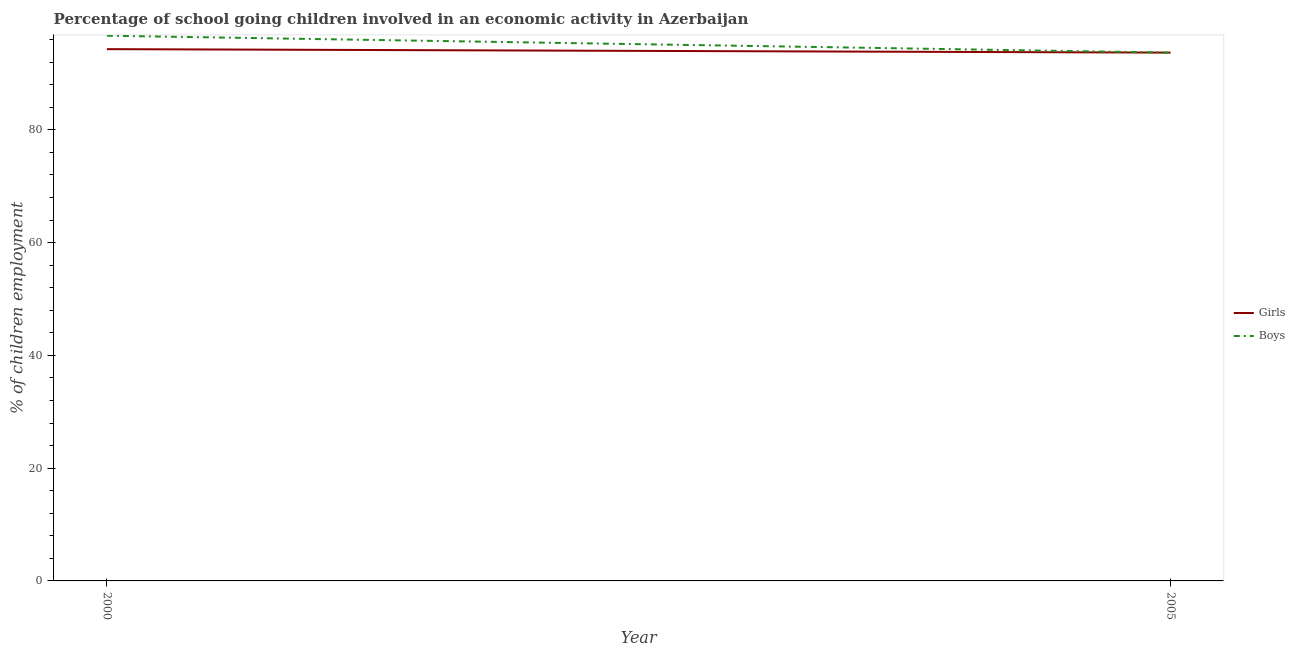Does the line corresponding to percentage of school going boys intersect with the line corresponding to percentage of school going girls?
Offer a terse response. Yes. What is the percentage of school going boys in 2005?
Ensure brevity in your answer.  93.7. Across all years, what is the maximum percentage of school going girls?
Your answer should be very brief. 94.32. Across all years, what is the minimum percentage of school going boys?
Your response must be concise. 93.7. In which year was the percentage of school going girls minimum?
Offer a very short reply. 2005. What is the total percentage of school going boys in the graph?
Your answer should be very brief. 190.4. What is the difference between the percentage of school going boys in 2000 and that in 2005?
Offer a very short reply. 3. What is the difference between the percentage of school going boys in 2005 and the percentage of school going girls in 2000?
Keep it short and to the point. -0.62. What is the average percentage of school going girls per year?
Provide a succinct answer. 94.01. In how many years, is the percentage of school going boys greater than 64 %?
Keep it short and to the point. 2. What is the ratio of the percentage of school going boys in 2000 to that in 2005?
Offer a very short reply. 1.03. In how many years, is the percentage of school going boys greater than the average percentage of school going boys taken over all years?
Offer a very short reply. 1. Does the percentage of school going girls monotonically increase over the years?
Keep it short and to the point. No. Is the percentage of school going girls strictly greater than the percentage of school going boys over the years?
Provide a succinct answer. No. Is the percentage of school going girls strictly less than the percentage of school going boys over the years?
Offer a terse response. No. How many lines are there?
Offer a very short reply. 2. What is the difference between two consecutive major ticks on the Y-axis?
Your answer should be very brief. 20. Does the graph contain any zero values?
Your response must be concise. No. How many legend labels are there?
Your answer should be very brief. 2. What is the title of the graph?
Offer a terse response. Percentage of school going children involved in an economic activity in Azerbaijan. What is the label or title of the Y-axis?
Offer a very short reply. % of children employment. What is the % of children employment in Girls in 2000?
Ensure brevity in your answer.  94.32. What is the % of children employment in Boys in 2000?
Your answer should be compact. 96.7. What is the % of children employment of Girls in 2005?
Offer a very short reply. 93.7. What is the % of children employment in Boys in 2005?
Give a very brief answer. 93.7. Across all years, what is the maximum % of children employment in Girls?
Give a very brief answer. 94.32. Across all years, what is the maximum % of children employment in Boys?
Your response must be concise. 96.7. Across all years, what is the minimum % of children employment in Girls?
Your answer should be very brief. 93.7. Across all years, what is the minimum % of children employment in Boys?
Make the answer very short. 93.7. What is the total % of children employment of Girls in the graph?
Ensure brevity in your answer.  188.02. What is the total % of children employment of Boys in the graph?
Make the answer very short. 190.4. What is the difference between the % of children employment of Girls in 2000 and that in 2005?
Offer a terse response. 0.62. What is the difference between the % of children employment in Boys in 2000 and that in 2005?
Your answer should be compact. 3. What is the difference between the % of children employment of Girls in 2000 and the % of children employment of Boys in 2005?
Ensure brevity in your answer.  0.62. What is the average % of children employment of Girls per year?
Provide a succinct answer. 94.01. What is the average % of children employment of Boys per year?
Give a very brief answer. 95.2. In the year 2000, what is the difference between the % of children employment of Girls and % of children employment of Boys?
Provide a succinct answer. -2.38. What is the ratio of the % of children employment of Girls in 2000 to that in 2005?
Provide a short and direct response. 1.01. What is the ratio of the % of children employment of Boys in 2000 to that in 2005?
Offer a very short reply. 1.03. What is the difference between the highest and the second highest % of children employment in Girls?
Your response must be concise. 0.62. What is the difference between the highest and the second highest % of children employment in Boys?
Your answer should be compact. 3. What is the difference between the highest and the lowest % of children employment of Girls?
Provide a short and direct response. 0.62. What is the difference between the highest and the lowest % of children employment in Boys?
Offer a terse response. 3. 